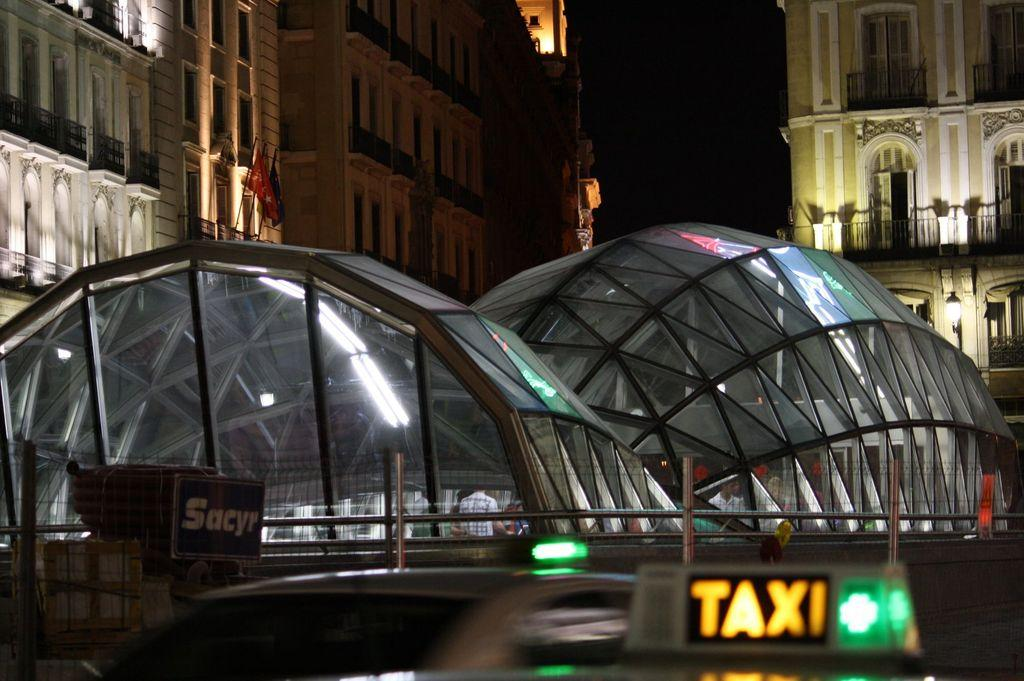What type of vehicle is in the image? The facts provided do not specify the type of vehicle in the image. What can be seen near the vehicle in the image? There is railing and boards visible near the vehicle in the image. What type of structures are in the image? There are sheds in the image. What can be seen in the background of the image? In the background, there are buildings with railing and windows visible. Can you find the receipt for the ant's argument in the image? There is no receipt or ant present in the image, nor is there any indication of an argument. 